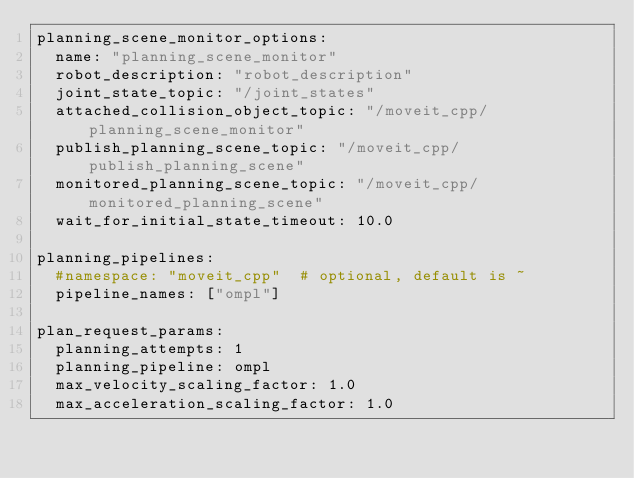Convert code to text. <code><loc_0><loc_0><loc_500><loc_500><_YAML_>planning_scene_monitor_options:
  name: "planning_scene_monitor"
  robot_description: "robot_description"
  joint_state_topic: "/joint_states"
  attached_collision_object_topic: "/moveit_cpp/planning_scene_monitor"
  publish_planning_scene_topic: "/moveit_cpp/publish_planning_scene"
  monitored_planning_scene_topic: "/moveit_cpp/monitored_planning_scene"
  wait_for_initial_state_timeout: 10.0

planning_pipelines:
  #namespace: "moveit_cpp"  # optional, default is ~
  pipeline_names: ["ompl"]

plan_request_params:
  planning_attempts: 1
  planning_pipeline: ompl
  max_velocity_scaling_factor: 1.0
  max_acceleration_scaling_factor: 1.0
</code> 